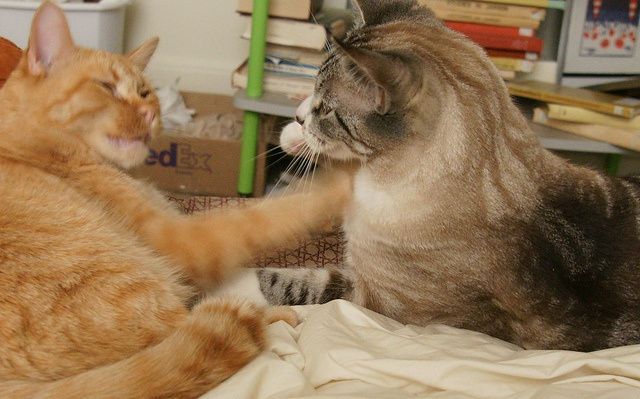Describe the objects in this image and their specific colors. I can see cat in darkgray, black, gray, maroon, and tan tones, cat in darkgray, tan, and olive tones, bed in darkgray and tan tones, book in darkgray, brown, gray, and maroon tones, and book in darkgray, tan, olive, and brown tones in this image. 